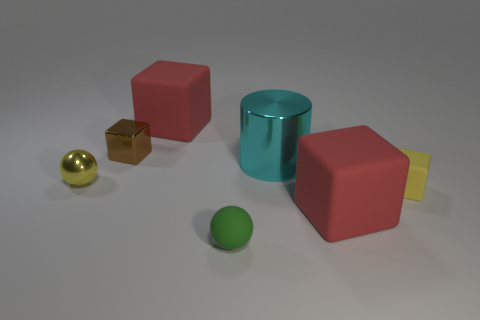Subtract all tiny yellow blocks. How many blocks are left? 3 Add 1 yellow metal things. How many objects exist? 8 Subtract 1 cylinders. How many cylinders are left? 0 Subtract all yellow cubes. How many cubes are left? 3 Subtract 0 blue blocks. How many objects are left? 7 Subtract all cubes. How many objects are left? 3 Subtract all green balls. Subtract all green cubes. How many balls are left? 1 Subtract all green cubes. How many yellow spheres are left? 1 Subtract all large purple shiny balls. Subtract all tiny green balls. How many objects are left? 6 Add 5 yellow things. How many yellow things are left? 7 